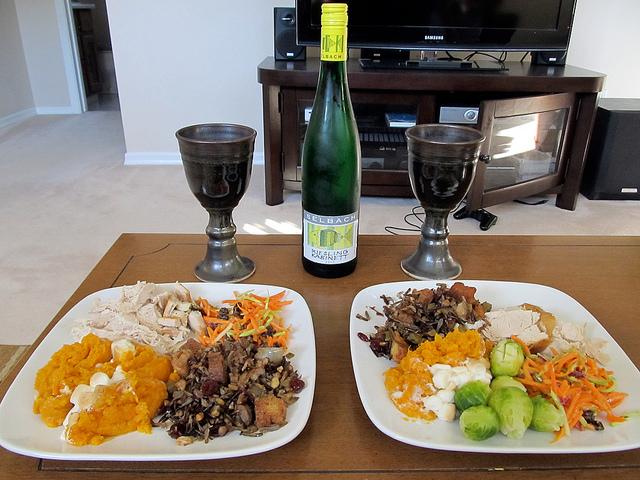Is this a high class meal?
Keep it brief. No. Are the plates the same?
Concise answer only. No. Do both plates have green veggies?
Quick response, please. No. Are there Brussels sprouts in the picture?
Write a very short answer. Yes. 